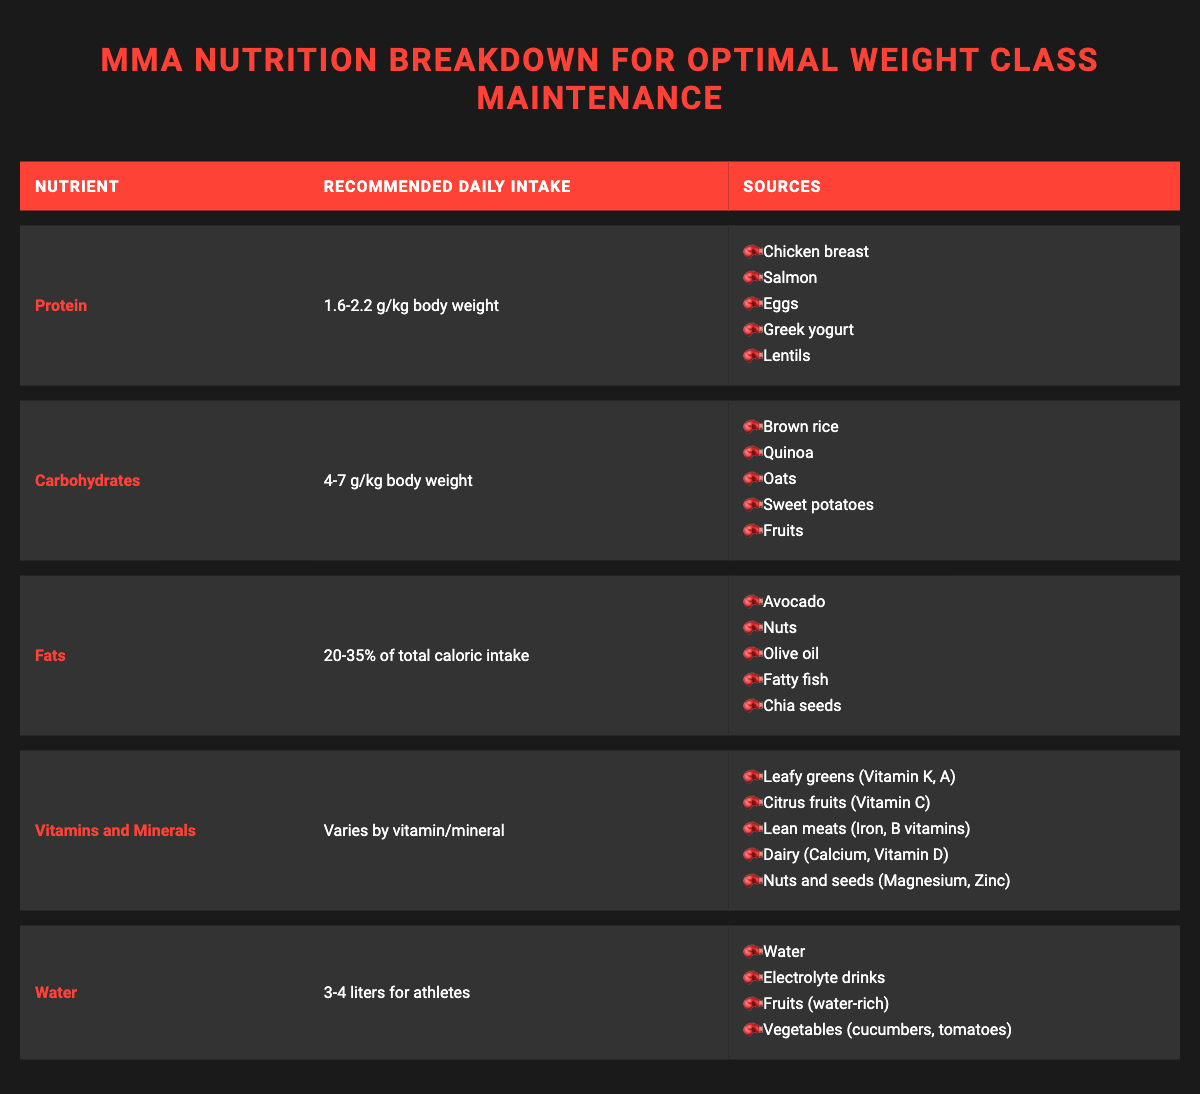What is the recommended daily intake of protein? The table lists the recommended daily intake of protein as "1.6-2.2 g/kg body weight."
Answer: 1.6-2.2 g/kg body weight How many sources of carbohydrates are listed in the table? The table provides a list of five sources of carbohydrates: brown rice, quinoa, oats, sweet potatoes, and fruits. Therefore, the number of sources is five.
Answer: 5 True or False: Fats should constitute 25% of total caloric intake according to the table. The table states that fats should be "20-35% of total caloric intake." Since 25% falls within this range, the statement is true.
Answer: True What is the difference in the recommended daily intake for protein and carbohydrates? The recommended daily intake for protein ranges from 1.6-2.2 g/kg body weight, while carbohydrates range from 4-7 g/kg body weight. To compare, we can say the difference in the lower limits is 4 g/kg - 1.6 g/kg = 2.4 g/kg, and in the upper limits is 7 g/kg - 2.2 g/kg = 4.8 g/kg.
Answer: 2.4-4.8 g/kg What is the total number of sources listed for fats? The table lists five sources of fats: avocado, nuts, olive oil, fatty fish, and chia seeds. Therefore, the total number of sources is five.
Answer: 5 Which nutrient has a varying recommended daily intake? The nutrient vitamins and minerals has a recommended daily intake described as "Varies by vitamin/mineral," indicating that it does not have a single value.
Answer: Vitamins and minerals What is the recommended daily intake of water for athletes? According to the table, athletes are recommended to consume "3-4 liters" of water daily.
Answer: 3-4 liters What are three sources of vitamins and minerals listed in the table? The table mentions several sources, three of which are leafy greens, citrus fruits, and lean meats.
Answer: Leafy greens, citrus fruits, lean meats 